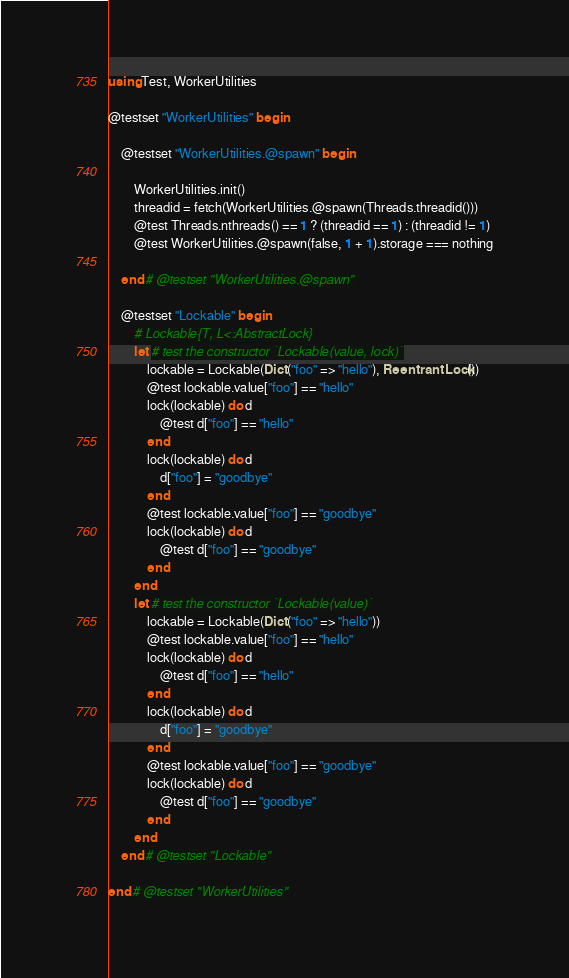Convert code to text. <code><loc_0><loc_0><loc_500><loc_500><_Julia_>using Test, WorkerUtilities

@testset "WorkerUtilities" begin

    @testset "WorkerUtilities.@spawn" begin

        WorkerUtilities.init()
        threadid = fetch(WorkerUtilities.@spawn(Threads.threadid()))
        @test Threads.nthreads() == 1 ? (threadid == 1) : (threadid != 1)
        @test WorkerUtilities.@spawn(false, 1 + 1).storage === nothing

    end # @testset "WorkerUtilities.@spawn"

    @testset "Lockable" begin
        # Lockable{T, L<:AbstractLock}
        let # test the constructor `Lockable(value, lock)`
            lockable = Lockable(Dict("foo" => "hello"), ReentrantLock())
            @test lockable.value["foo"] == "hello"
            lock(lockable) do d
                @test d["foo"] == "hello"
            end
            lock(lockable) do d
                d["foo"] = "goodbye"
            end
            @test lockable.value["foo"] == "goodbye"
            lock(lockable) do d
                @test d["foo"] == "goodbye"
            end
        end
        let # test the constructor `Lockable(value)`
            lockable = Lockable(Dict("foo" => "hello"))
            @test lockable.value["foo"] == "hello"
            lock(lockable) do d
                @test d["foo"] == "hello"
            end
            lock(lockable) do d
                d["foo"] = "goodbye"
            end
            @test lockable.value["foo"] == "goodbye"
            lock(lockable) do d
                @test d["foo"] == "goodbye"
            end
        end
    end # @testset "Lockable"

end # @testset "WorkerUtilities"</code> 